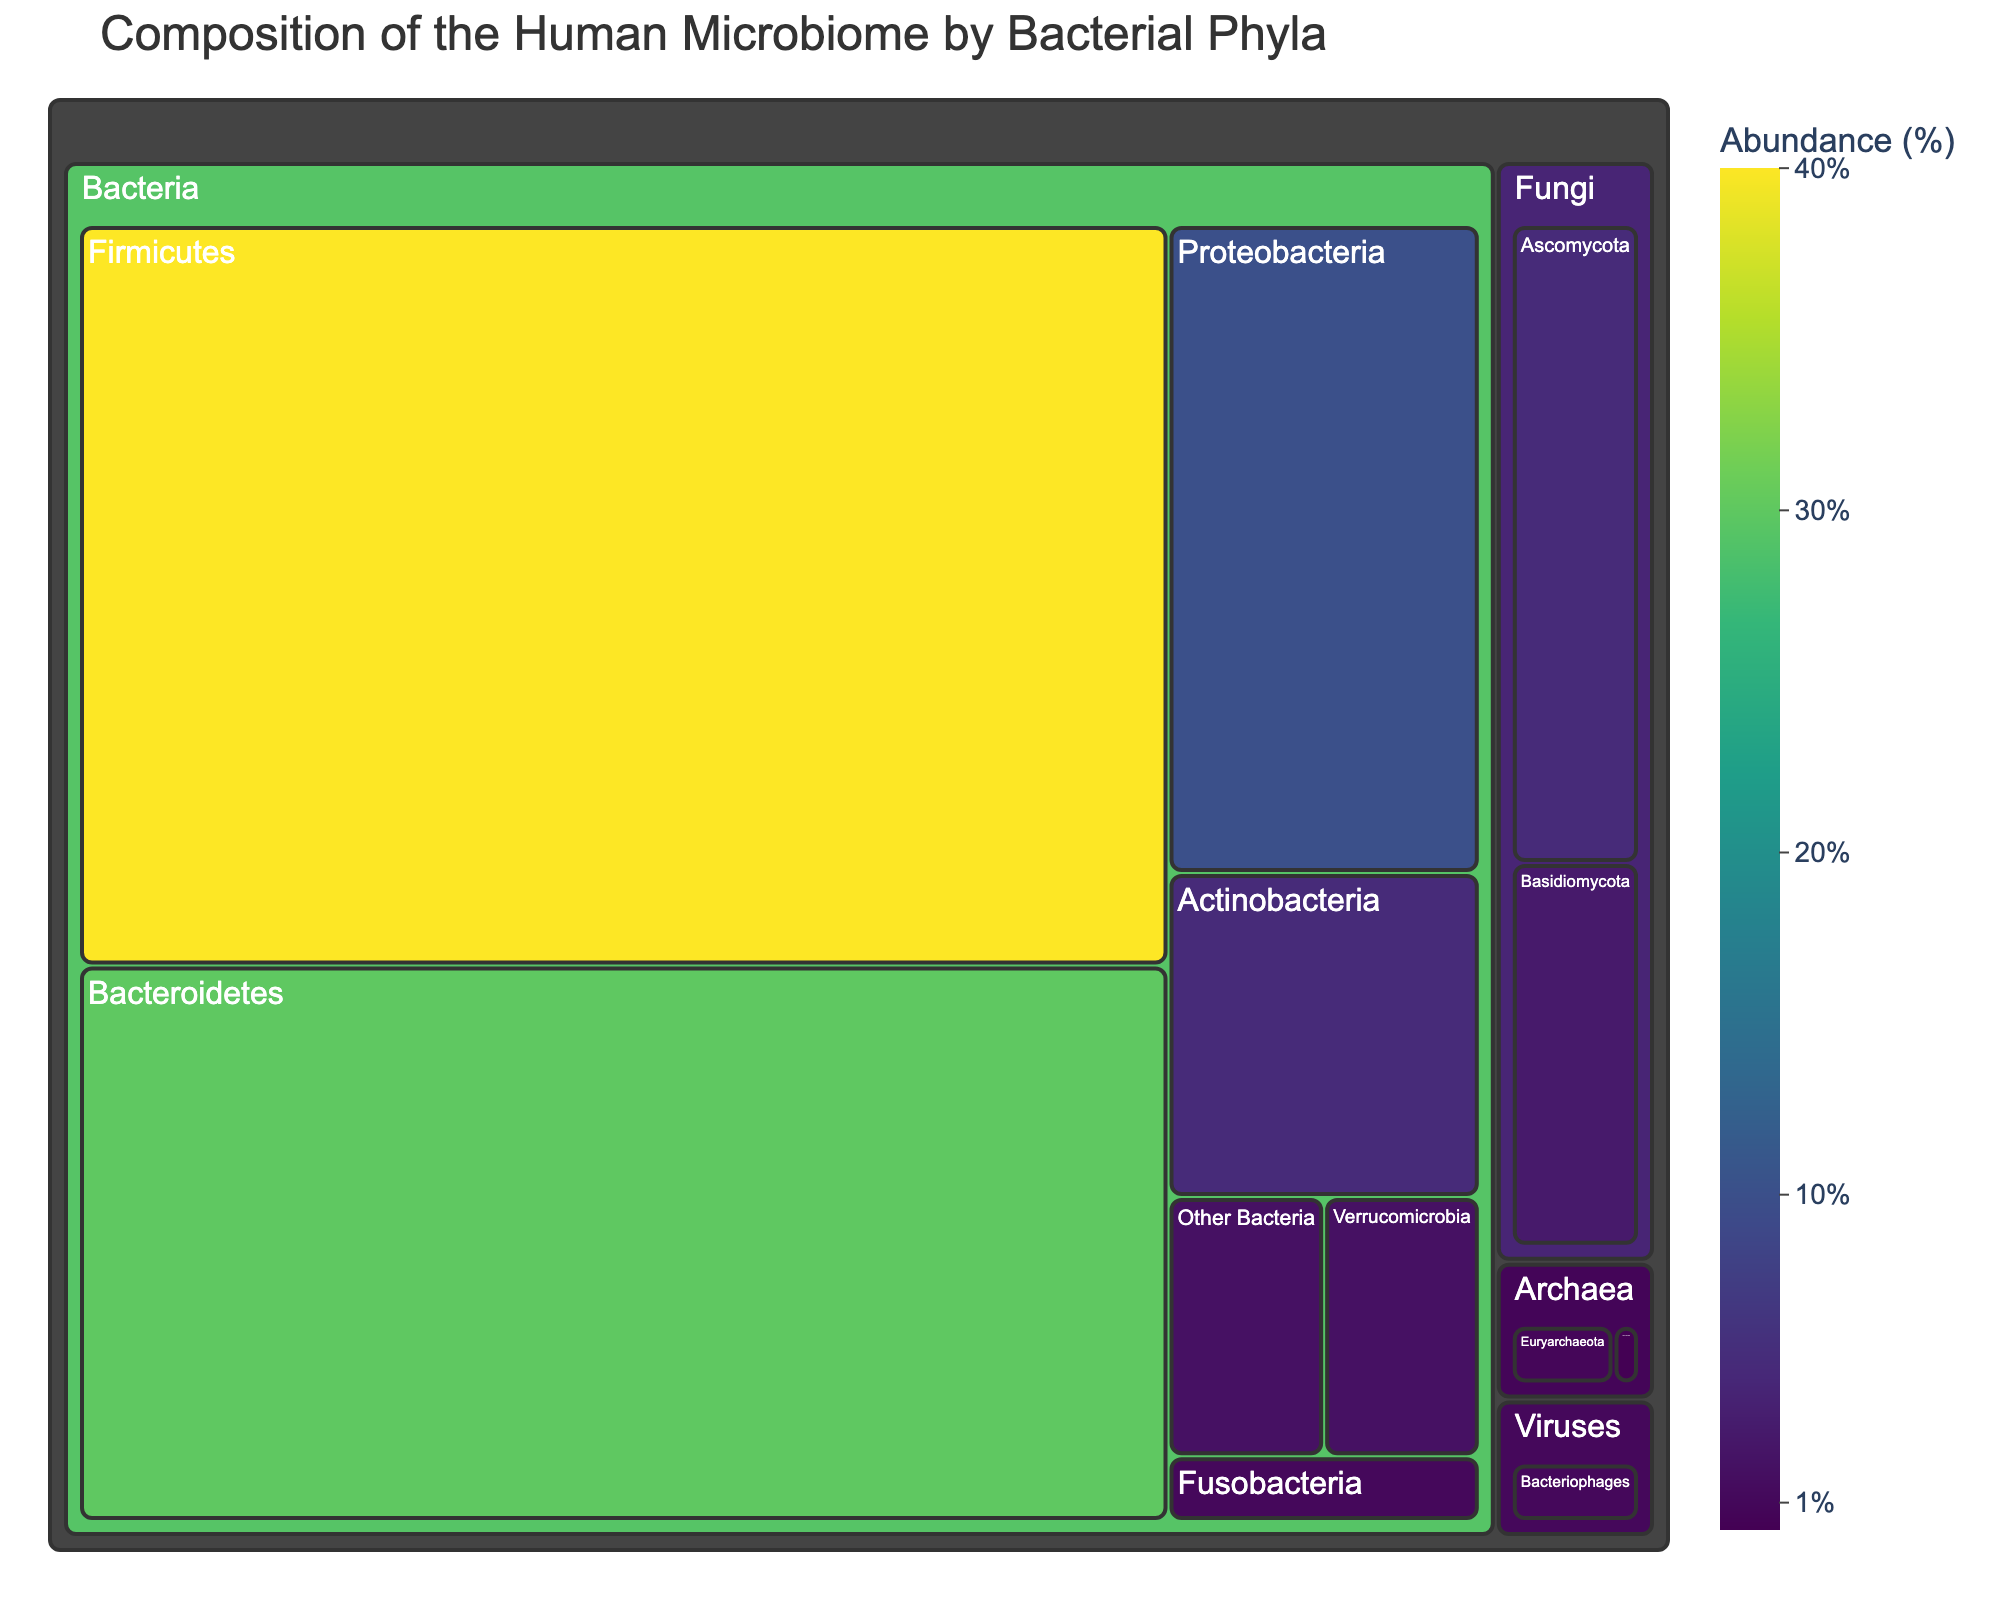what is the title of the figure? The title is usually displayed at the top of the figure and provides a summary of what the figure represents. The title here is "Composition of the Human Microbiome by Bacterial Phyla".
Answer: Composition of the Human Microbiome by Bacterial Phyla Which bacterial phylum has the highest abundance? By looking at the size of the sections in the treemap, the one with the greatest area represents the highest abundance. Firmicutes has the largest section in the figure.
Answer: Firmicutes How many unique categories are represented in this treemap? Categories typically refer to the top-level groupings in a treemap. Here, visually inspecting the treemap, we see labels like Bacteria, Archaea, Fungi, and Viruses. Counting these gives four categories.
Answer: 4 What is the combined abundance of Actinobacteria and Verrucomicrobia? To find the combined abundance, we sum the values of Actinobacteria (5%) and Verrucomicrobia (2%). 5% + 2% = 7%.
Answer: 7% Which category has the least abundant phylum, and what is it? The least abundant section can be identified by finding the smallest section in the treemap. Here, "Other Archaea" under the category Archaea has the least abundance at 0.2%.
Answer: Archaea, Other Archaea Compare the abundance of Bacteroidetes and Proteobacteria. Which one is more abundant and by how much? To compare, we subtract the smaller abundance from the larger one: Bacteroidetes (30%) - Proteobacteria (10%) = 20%. So, Bacteroidetes is more abundant by 20%.
Answer: Bacteroidetes, 20% What is the total abundance of all bacterial phyla combined? To find the total abundance of bacterial phyla, we add the abundances of Firmicutes (40%), Bacteroidetes (30%), Proteobacteria (10%), Actinobacteria (5%), Verrucomicrobia (2%), Fusobacteria (1%), and Other Bacteria (2%). 40% + 30% + 10% + 5% + 2% + 1% + 2% = 90%.
Answer: 90% Which category does Ascomycota belong to and what is its abundance? Looking at the treemap, Ascomycota is under the Fungi category with an abundance of 5%.
Answer: Fungi, 5% Is the abundance of Bacteriophages greater than Fusobacteria? By comparing the abundances visually or numerically: Bacteriophages (1%) and Fusobacteria (1%). Both have the same abundance, so one is not greater than the other.
Answer: No Calculate the percentage contribution of Ascomycota and Basidiomycota to the total abundance of the microbiome. First, find the combined abundance of Ascomycota (5%) and Basidiomycota (3%), which is 8%. Then convert this to a percentage of the total (100%): (8/100) * 100 = 8%.
Answer: 8% 